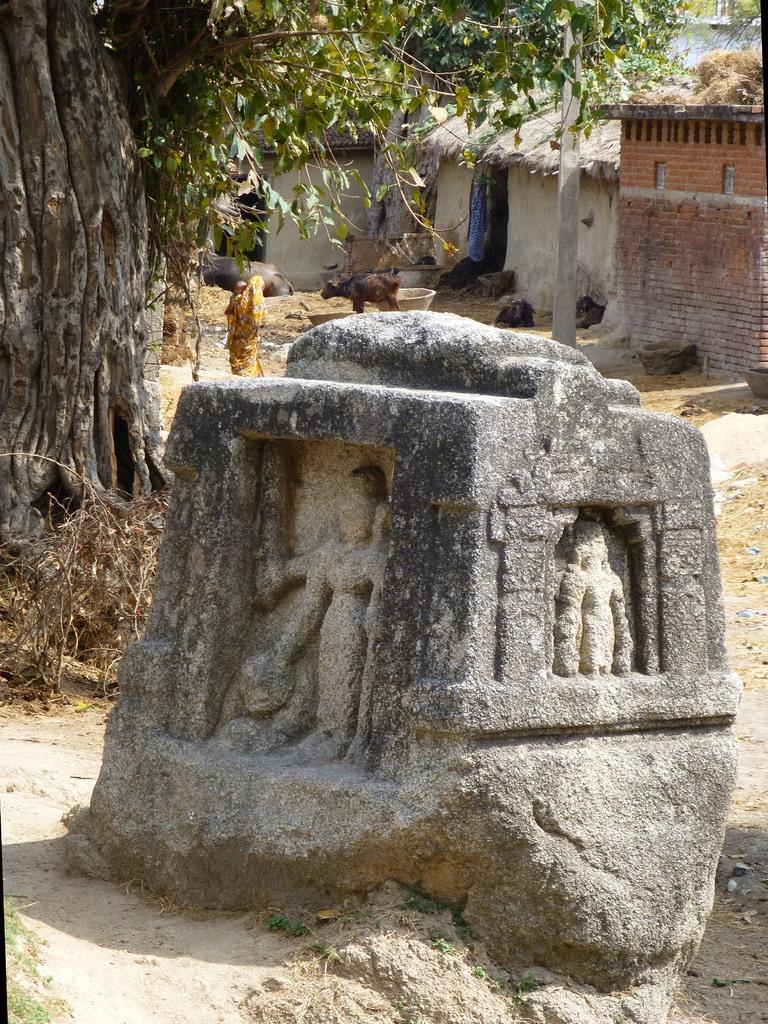Please provide a concise description of this image. In this image we can a rock to which there are some sculptures and behind there are some houses, trees and some other things. 